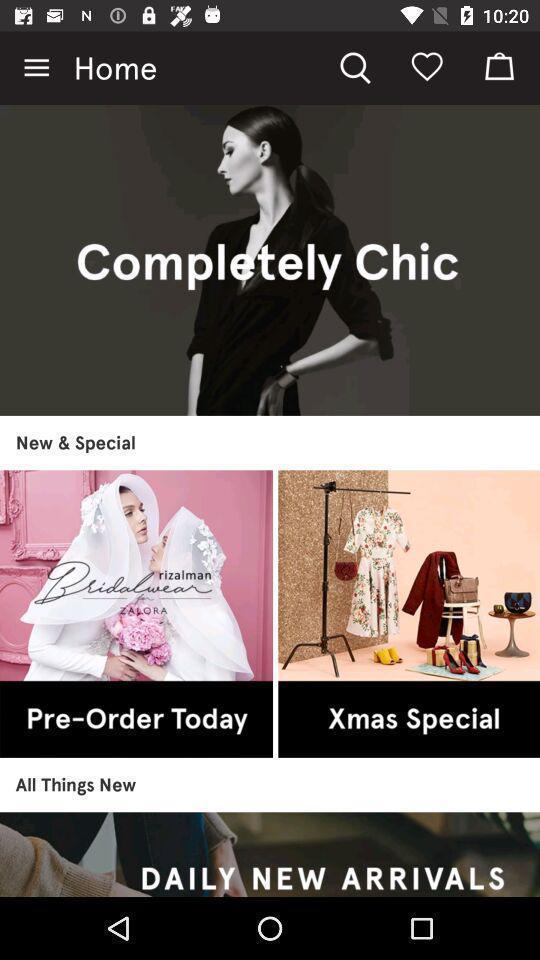Explain what's happening in this screen capture. Various fashion details displayed of a online shopping app. 